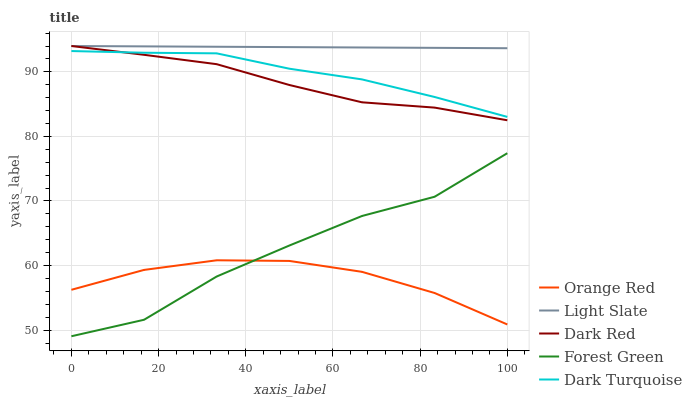Does Dark Red have the minimum area under the curve?
Answer yes or no. No. Does Dark Red have the maximum area under the curve?
Answer yes or no. No. Is Dark Red the smoothest?
Answer yes or no. No. Is Dark Red the roughest?
Answer yes or no. No. Does Dark Red have the lowest value?
Answer yes or no. No. Does Forest Green have the highest value?
Answer yes or no. No. Is Orange Red less than Dark Turquoise?
Answer yes or no. Yes. Is Dark Red greater than Forest Green?
Answer yes or no. Yes. Does Orange Red intersect Dark Turquoise?
Answer yes or no. No. 